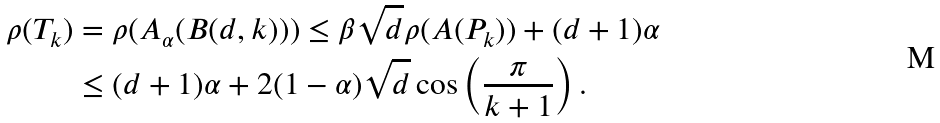Convert formula to latex. <formula><loc_0><loc_0><loc_500><loc_500>\rho ( T _ { k } ) & = \rho ( A _ { \alpha } ( B ( d , k ) ) ) \leq \beta \sqrt { d } \rho ( A ( P _ { k } ) ) + ( d + 1 ) \alpha \\ & \leq ( d + 1 ) \alpha + 2 ( 1 - \alpha ) \sqrt { d } \cos \left ( \frac { \pi } { k + 1 } \right ) .</formula> 